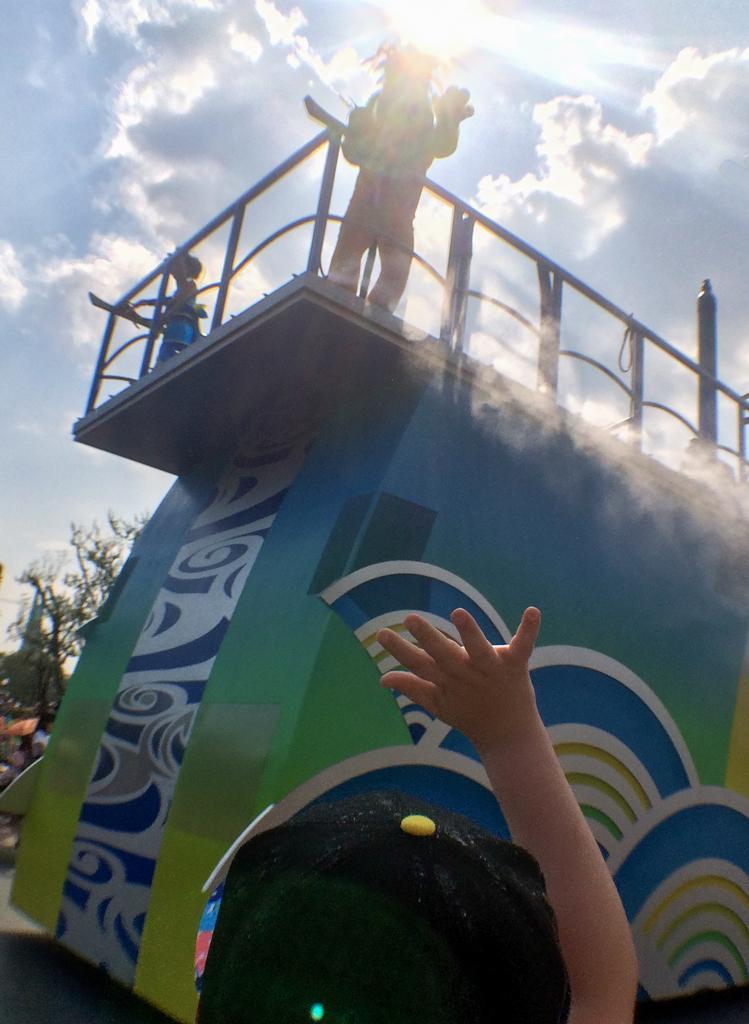Can you describe this image briefly? In the center of the image we can see two persons are standing on a vehicle and we can see tree, some persons are there. At the bottom of the image we can see road and person are there. At the top of the image clouds are present in the sky. 